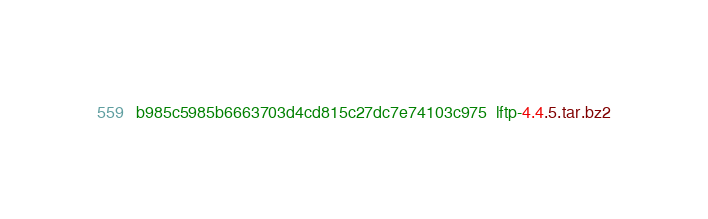<code> <loc_0><loc_0><loc_500><loc_500><_SML_>b985c5985b6663703d4cd815c27dc7e74103c975  lftp-4.4.5.tar.bz2
</code> 